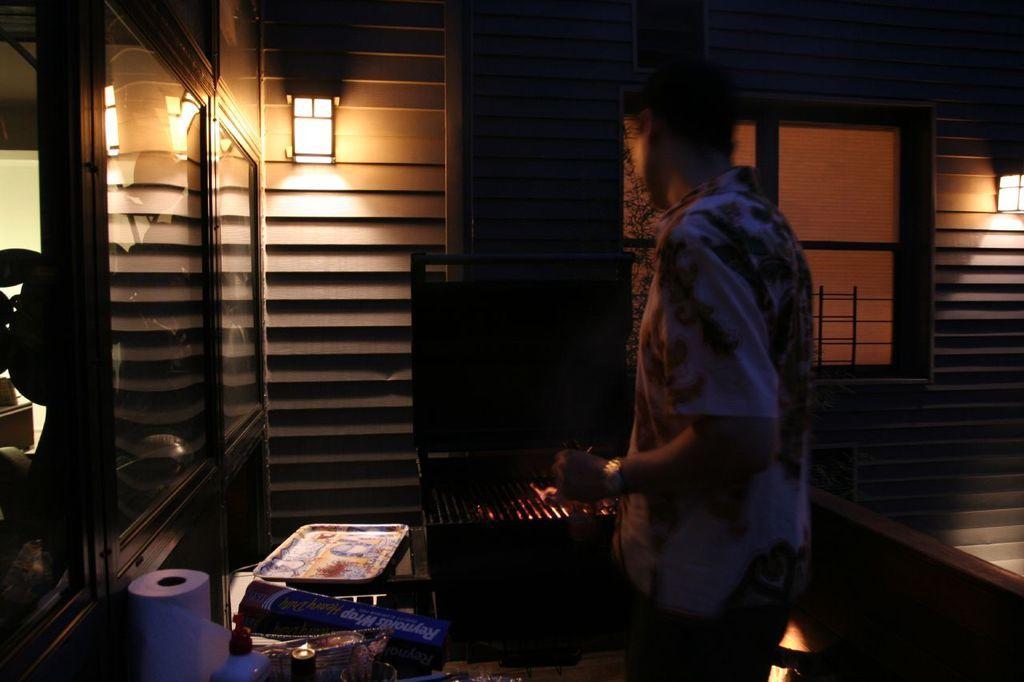Can you describe this image briefly? In the middle of the image there is a man standing. Beside him there is a grill. In front of him there is a table with tissue roll and few other items on it. On the left corner there is a glass door. In the background there is a wall with lamps and window. 